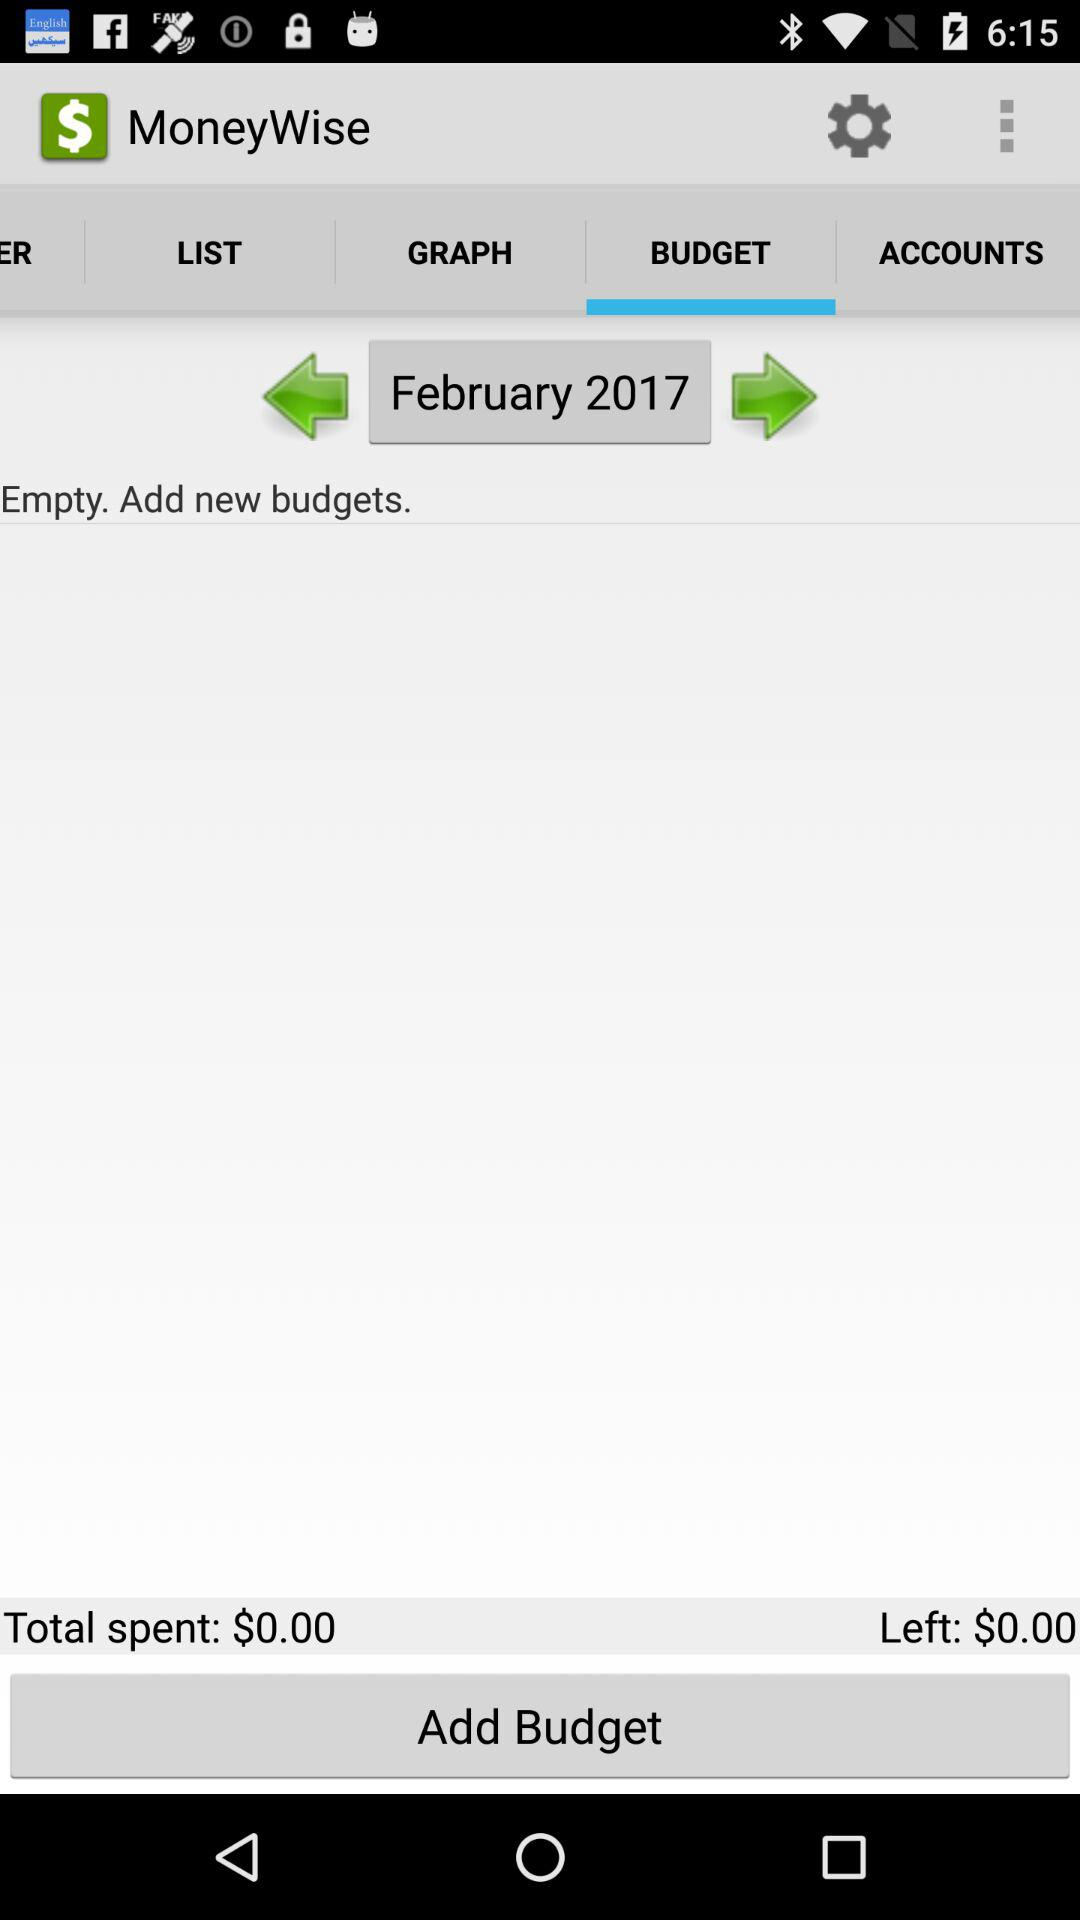How much money have I spent so far this month?
Answer the question using a single word or phrase. $0.00 